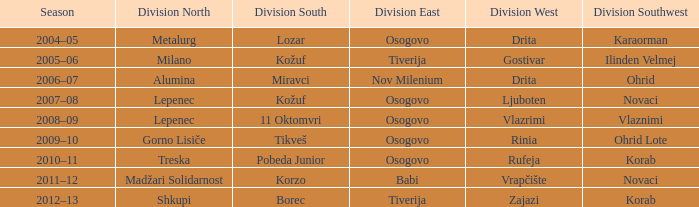When madžari solidarnost emerged victorious in division north, who claimed the win in division southwest? Novaci. 